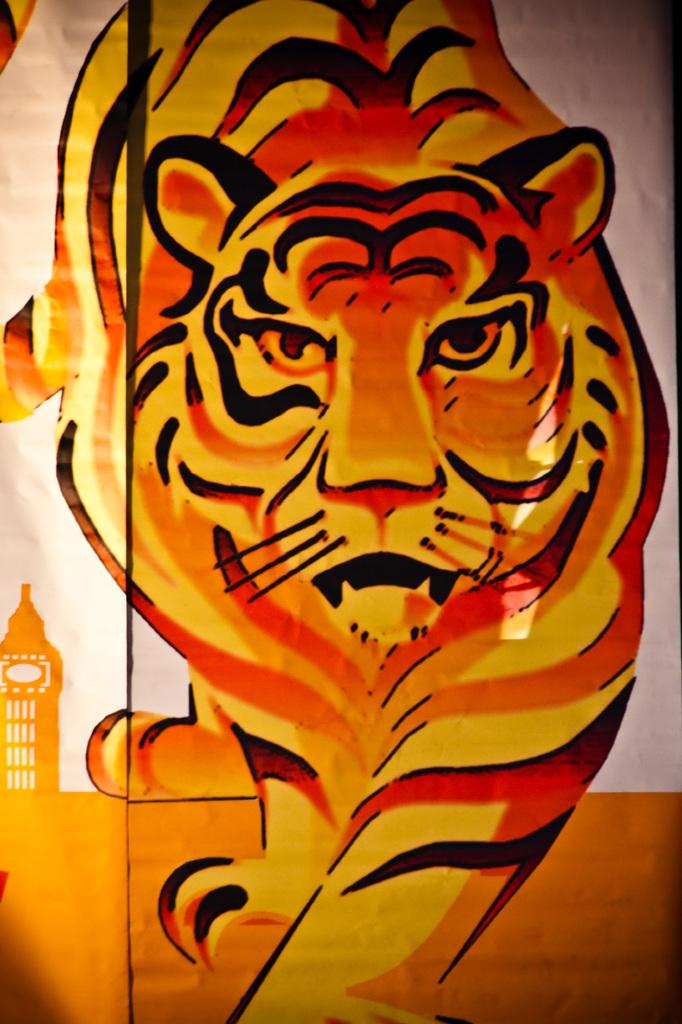What is the main subject of the painting in the image? The painting depicts a tiger. What colors are used in the painting? The colors of the painting include black and orange. How does the painting lead the group of animals in the image? The painting does not lead any group of animals in the image; it is a static image of a tiger. What type of weather is depicted in the painting? The painting does not depict any weather conditions; it is a painting of a tiger with no background or context provided. 